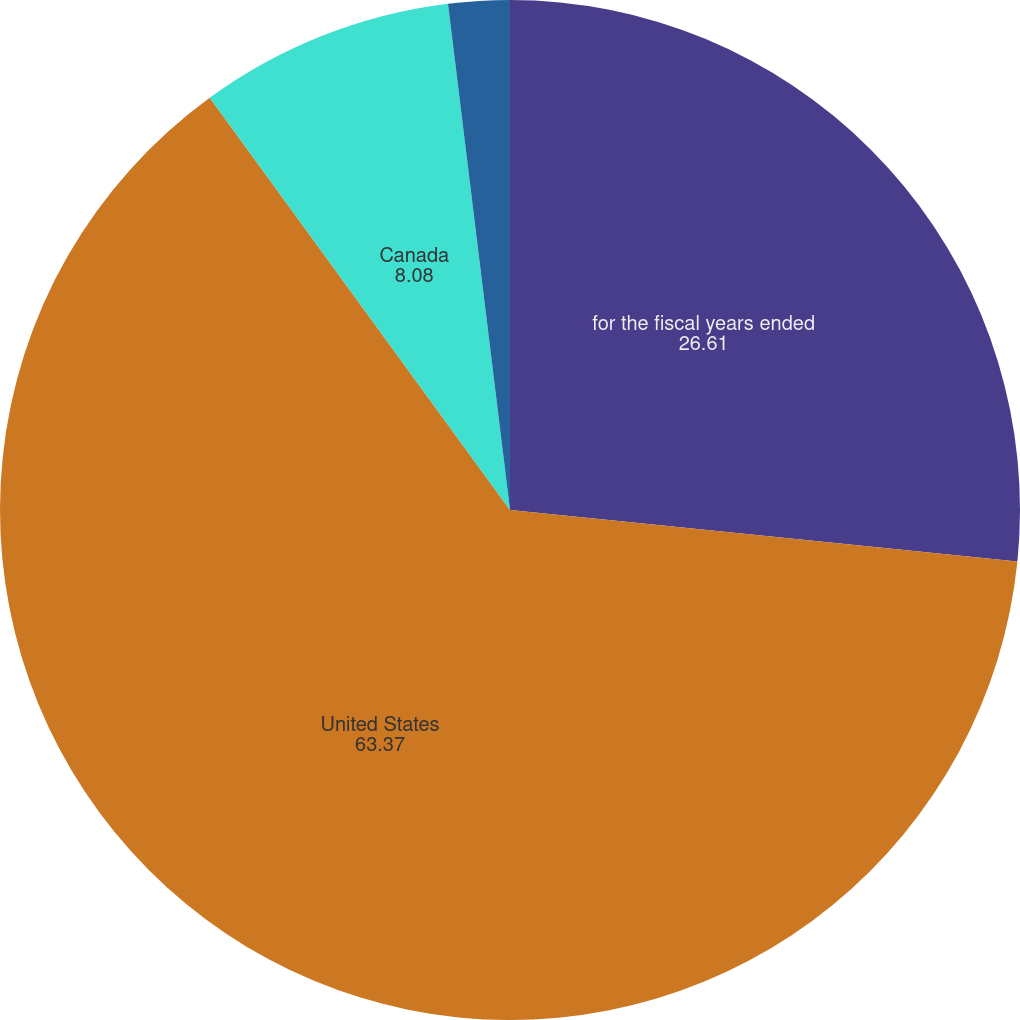<chart> <loc_0><loc_0><loc_500><loc_500><pie_chart><fcel>for the fiscal years ended<fcel>United States<fcel>Canada<fcel>Europe the Middle East and<nl><fcel>26.61%<fcel>63.37%<fcel>8.08%<fcel>1.94%<nl></chart> 